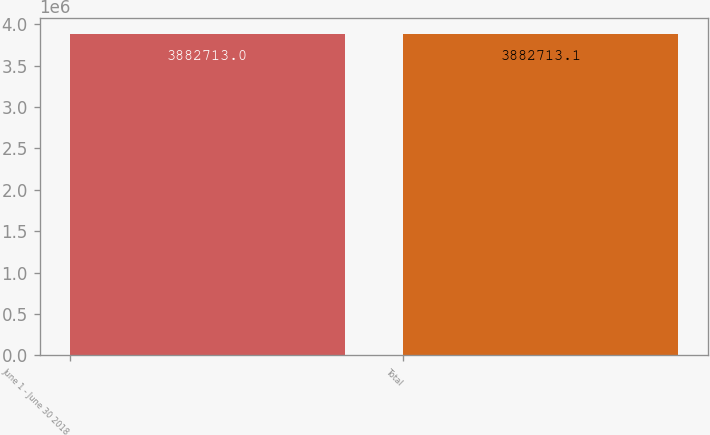<chart> <loc_0><loc_0><loc_500><loc_500><bar_chart><fcel>June 1 - June 30 2018<fcel>Total<nl><fcel>3.88271e+06<fcel>3.88271e+06<nl></chart> 